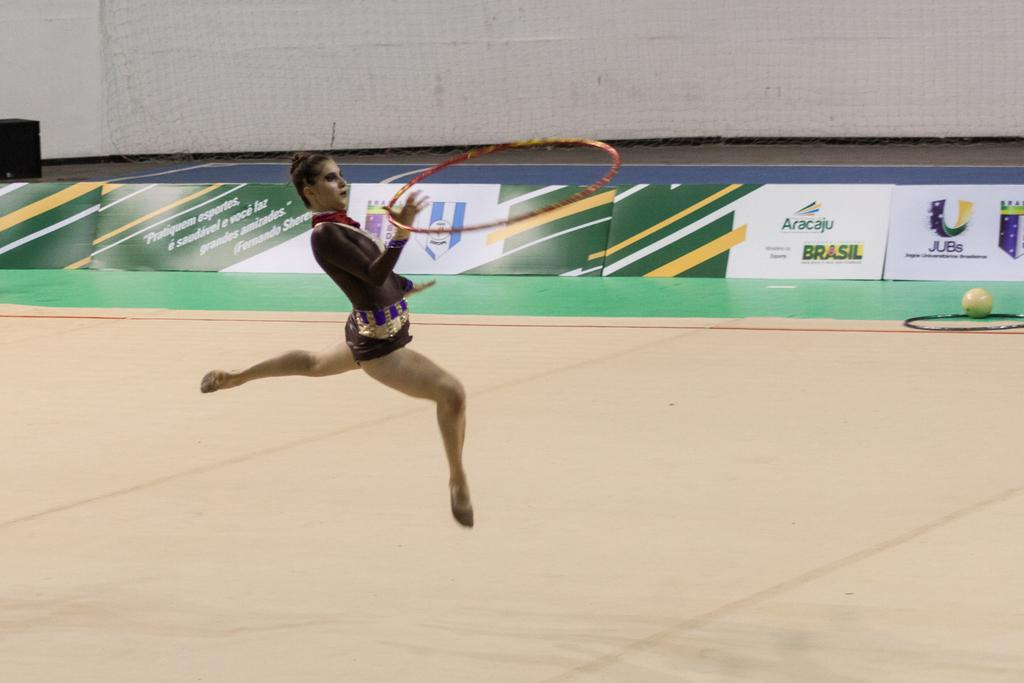Provide a one-sentence caption for the provided image. An Aracaju advertisement on the wall of a gymnastics competition. 